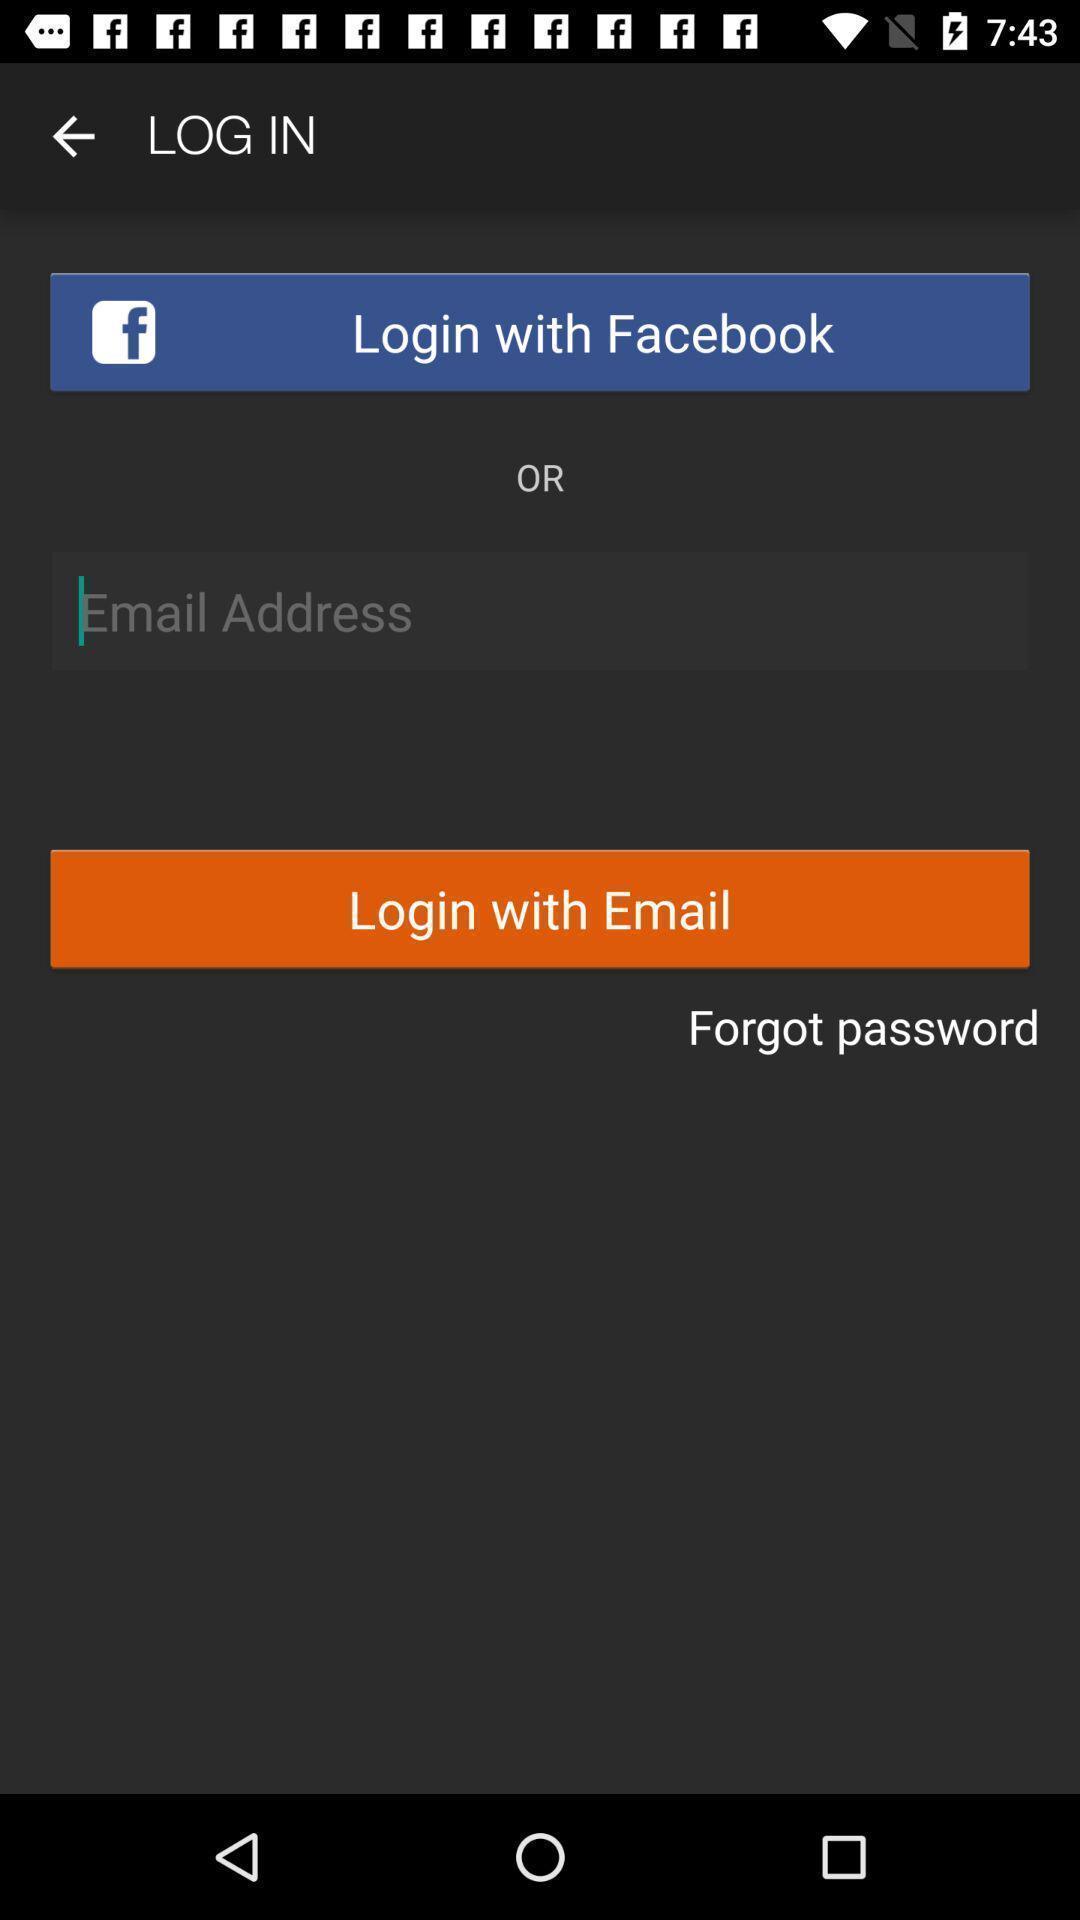What can you discern from this picture? Screen display login page. 